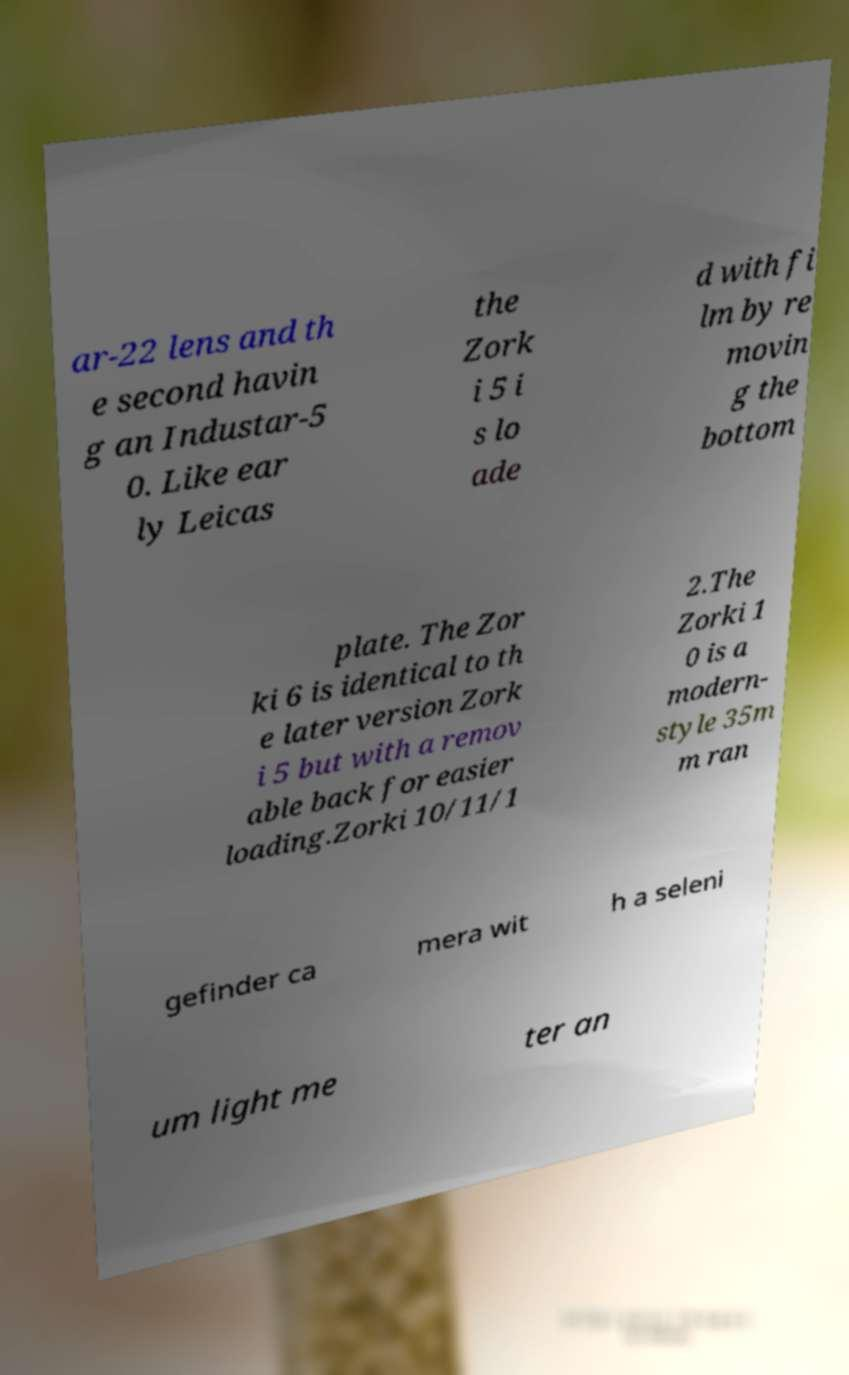Can you accurately transcribe the text from the provided image for me? ar-22 lens and th e second havin g an Industar-5 0. Like ear ly Leicas the Zork i 5 i s lo ade d with fi lm by re movin g the bottom plate. The Zor ki 6 is identical to th e later version Zork i 5 but with a remov able back for easier loading.Zorki 10/11/1 2.The Zorki 1 0 is a modern- style 35m m ran gefinder ca mera wit h a seleni um light me ter an 